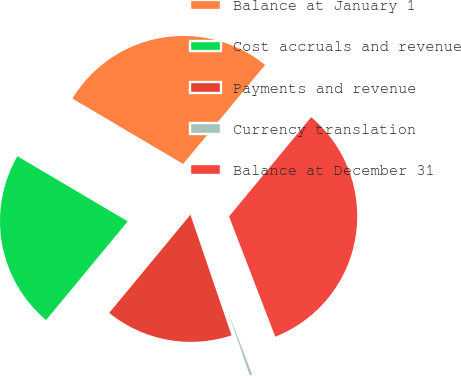<chart> <loc_0><loc_0><loc_500><loc_500><pie_chart><fcel>Balance at January 1<fcel>Cost accruals and revenue<fcel>Payments and revenue<fcel>Currency translation<fcel>Balance at December 31<nl><fcel>27.51%<fcel>22.49%<fcel>16.23%<fcel>0.61%<fcel>33.16%<nl></chart> 